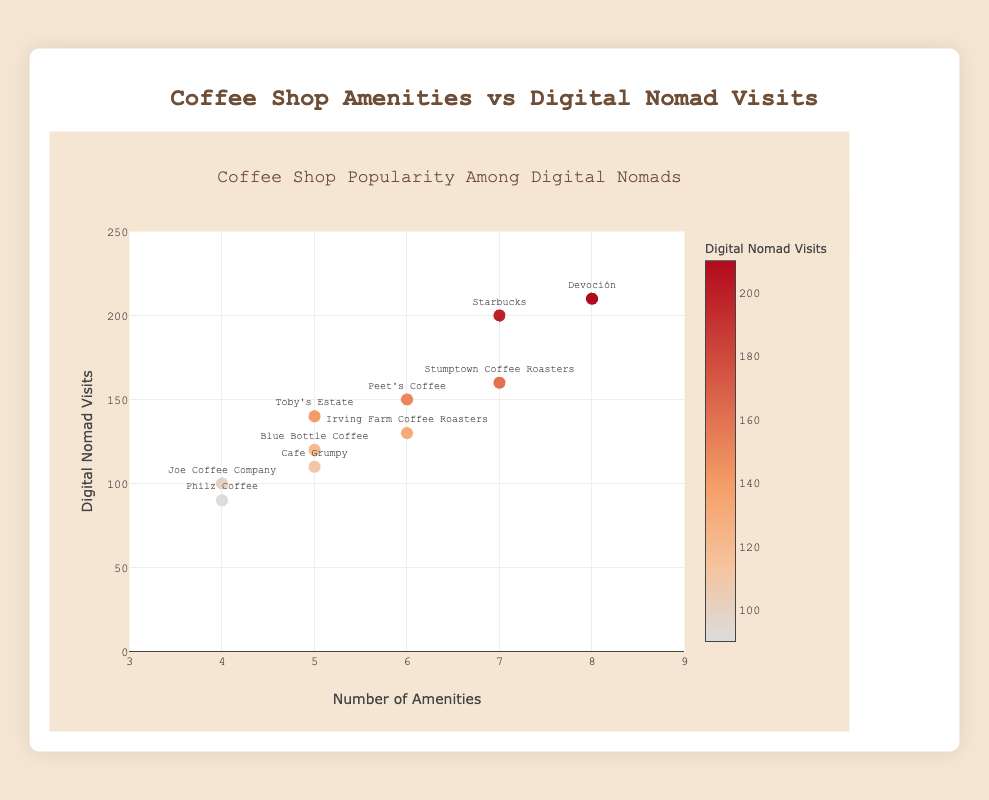What is the title of the scatter plot? The title is displayed at the top center in a slightly larger font. It reads "Coffee Shop Popularity Among Digital Nomads."
Answer: Coffee Shop Popularity Among Digital Nomads How many coffee shops have exactly 5 amenities? By looking at the x-axis where the number of amenities is 5 and counting the data points on the scatter plot at this value, we can see there are three coffee shops.
Answer: Three Which coffee shop has the highest number of digital nomad visits? By examining the y-axis for the highest value and checking the corresponding data point label, we find that "Devoción" has the highest visits.
Answer: Devoción What is the range of digital nomad visits displayed on the y-axis? The y-axis starts at 0 and goes up to 250 as indicated by the ticks on the axis.
Answer: 0 to 250 What is the coffee shop with 4 amenities and the highest digital nomad visits? From the x-axis, locate where amenities_count is 4 and then find the highest y value among those points. The corresponding label is for "Joe Coffee Company."
Answer: Joe Coffee Company How many coffee shops have more than 6 amenities? Counting the data points on the scatter plot where the x value (number of amenities) is greater than 6 shows three coffee shops.
Answer: Three Which coffee shop has 6 amenities and how many digital nomad visits does it have? Locate the data points at x=6 on the scatter plot and match them with their y values. The corresponding data points are for "Peet's Coffee" and "Irving Farm Coffee Roasters" with 150 and 130 visits respectively.
Answer: Peet's Coffee (150), Irving Farm Coffee Roasters (130) What is the average number of digital nomad visits for coffee shops with 5 amenities? The coffee shops with 5 amenities are Blue Bottle Coffee, Cafe Grumpy, and Toby's Estate with visits of 120, 110, and 140 respectively. Summing these and dividing by the number of coffee shops: (120 + 110 + 140) / 3 = 370 / 3 = 123.33
Answer: 123.33 Which coffee shops have the same number of amenities but different digital nomad visits? Identify coffee shops with the same x value but different y values. For example, "Starbucks" and "Stumptown Coffee Roasters" both have 7 amenities but different visits (200 and 160).
Answer: Starbucks and Stumptown Coffee Roasters 